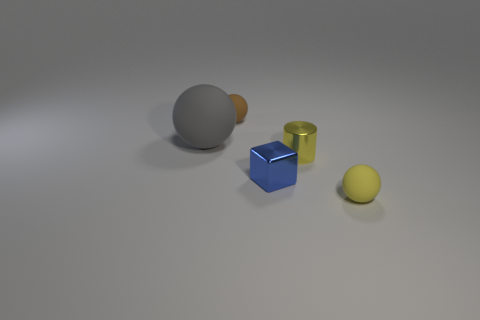Add 3 cubes. How many objects exist? 8 Subtract 1 spheres. How many spheres are left? 2 Subtract all cylinders. How many objects are left? 4 Subtract 0 green cylinders. How many objects are left? 5 Subtract all brown balls. Subtract all large gray objects. How many objects are left? 3 Add 3 tiny brown spheres. How many tiny brown spheres are left? 4 Add 4 small metallic cylinders. How many small metallic cylinders exist? 5 